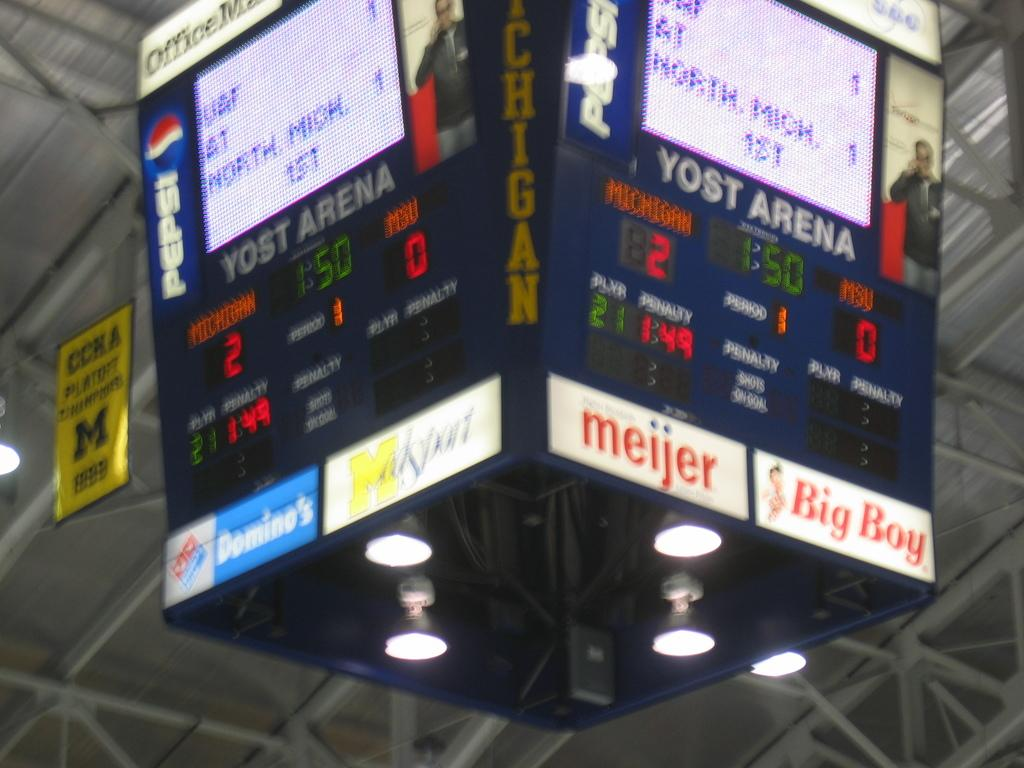<image>
Give a short and clear explanation of the subsequent image. an overhead display showing sponsors such as meijer 